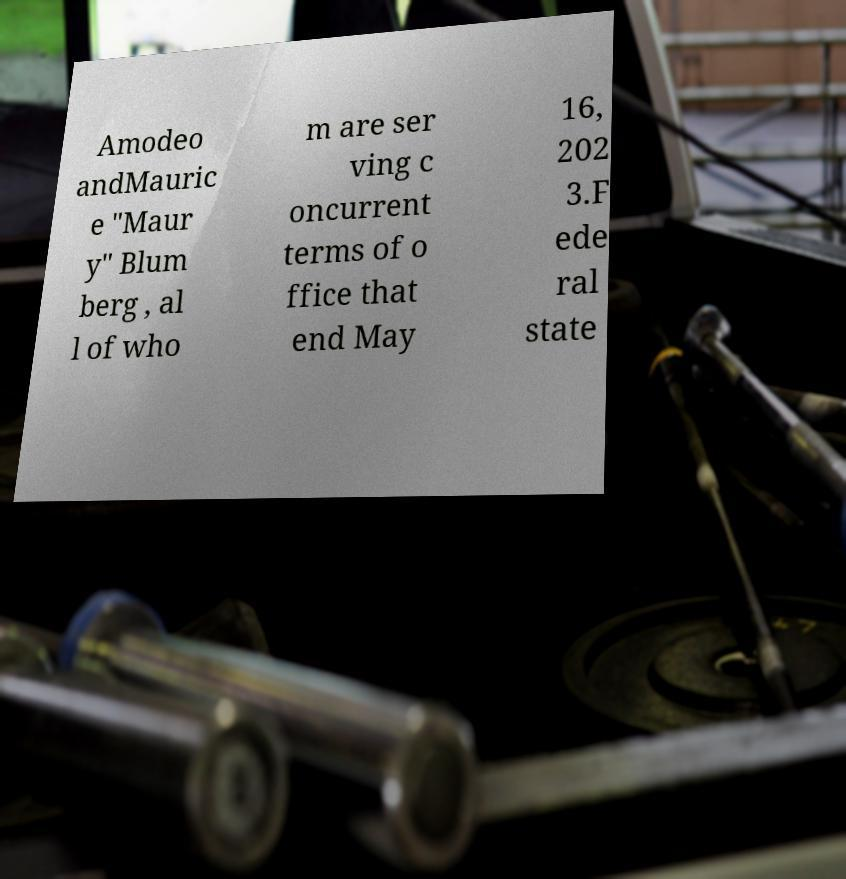Please read and relay the text visible in this image. What does it say? Amodeo andMauric e "Maur y" Blum berg , al l of who m are ser ving c oncurrent terms of o ffice that end May 16, 202 3.F ede ral state 